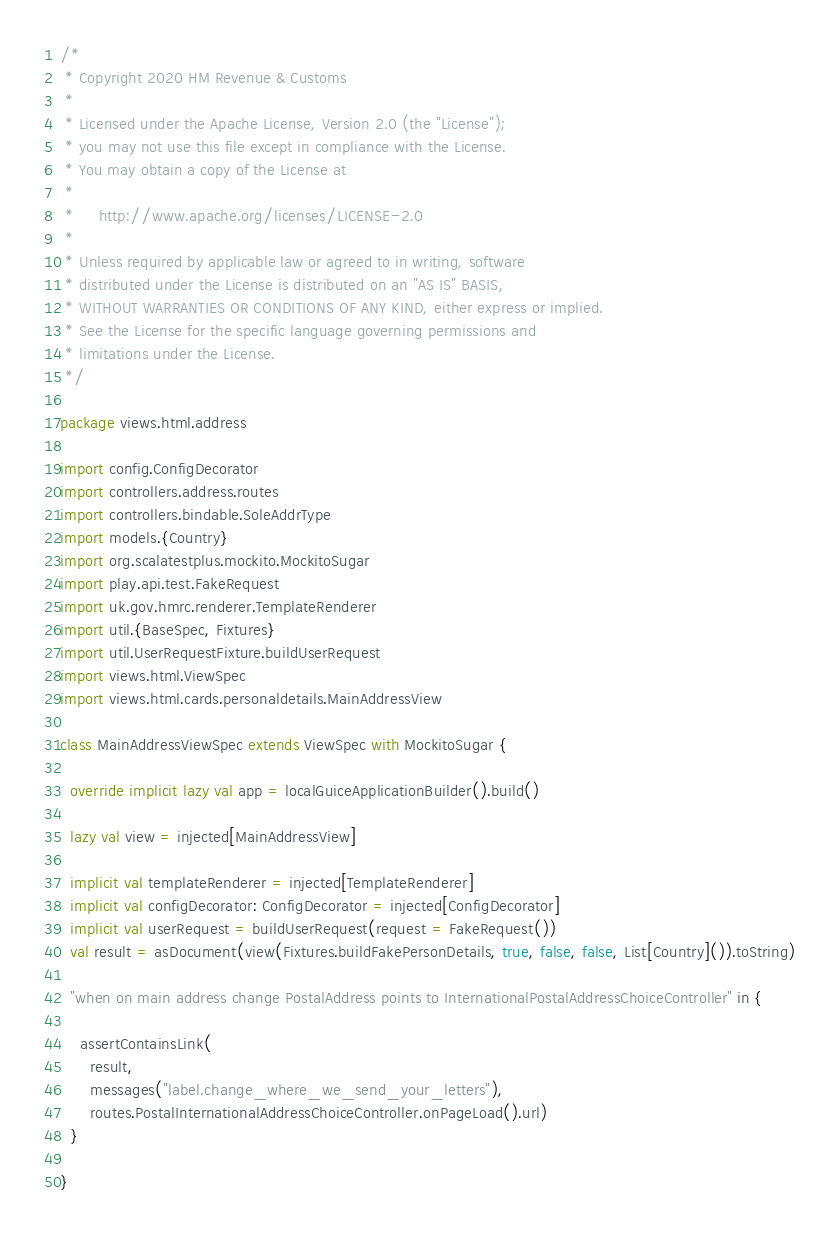Convert code to text. <code><loc_0><loc_0><loc_500><loc_500><_Scala_>/*
 * Copyright 2020 HM Revenue & Customs
 *
 * Licensed under the Apache License, Version 2.0 (the "License");
 * you may not use this file except in compliance with the License.
 * You may obtain a copy of the License at
 *
 *     http://www.apache.org/licenses/LICENSE-2.0
 *
 * Unless required by applicable law or agreed to in writing, software
 * distributed under the License is distributed on an "AS IS" BASIS,
 * WITHOUT WARRANTIES OR CONDITIONS OF ANY KIND, either express or implied.
 * See the License for the specific language governing permissions and
 * limitations under the License.
 */

package views.html.address

import config.ConfigDecorator
import controllers.address.routes
import controllers.bindable.SoleAddrType
import models.{Country}
import org.scalatestplus.mockito.MockitoSugar
import play.api.test.FakeRequest
import uk.gov.hmrc.renderer.TemplateRenderer
import util.{BaseSpec, Fixtures}
import util.UserRequestFixture.buildUserRequest
import views.html.ViewSpec
import views.html.cards.personaldetails.MainAddressView

class MainAddressViewSpec extends ViewSpec with MockitoSugar {

  override implicit lazy val app = localGuiceApplicationBuilder().build()

  lazy val view = injected[MainAddressView]

  implicit val templateRenderer = injected[TemplateRenderer]
  implicit val configDecorator: ConfigDecorator = injected[ConfigDecorator]
  implicit val userRequest = buildUserRequest(request = FakeRequest())
  val result = asDocument(view(Fixtures.buildFakePersonDetails, true, false, false, List[Country]()).toString)

  "when on main address change PostalAddress points to InternationalPostalAddressChoiceController" in {

    assertContainsLink(
      result,
      messages("label.change_where_we_send_your_letters"),
      routes.PostalInternationalAddressChoiceController.onPageLoad().url)
  }

}
</code> 